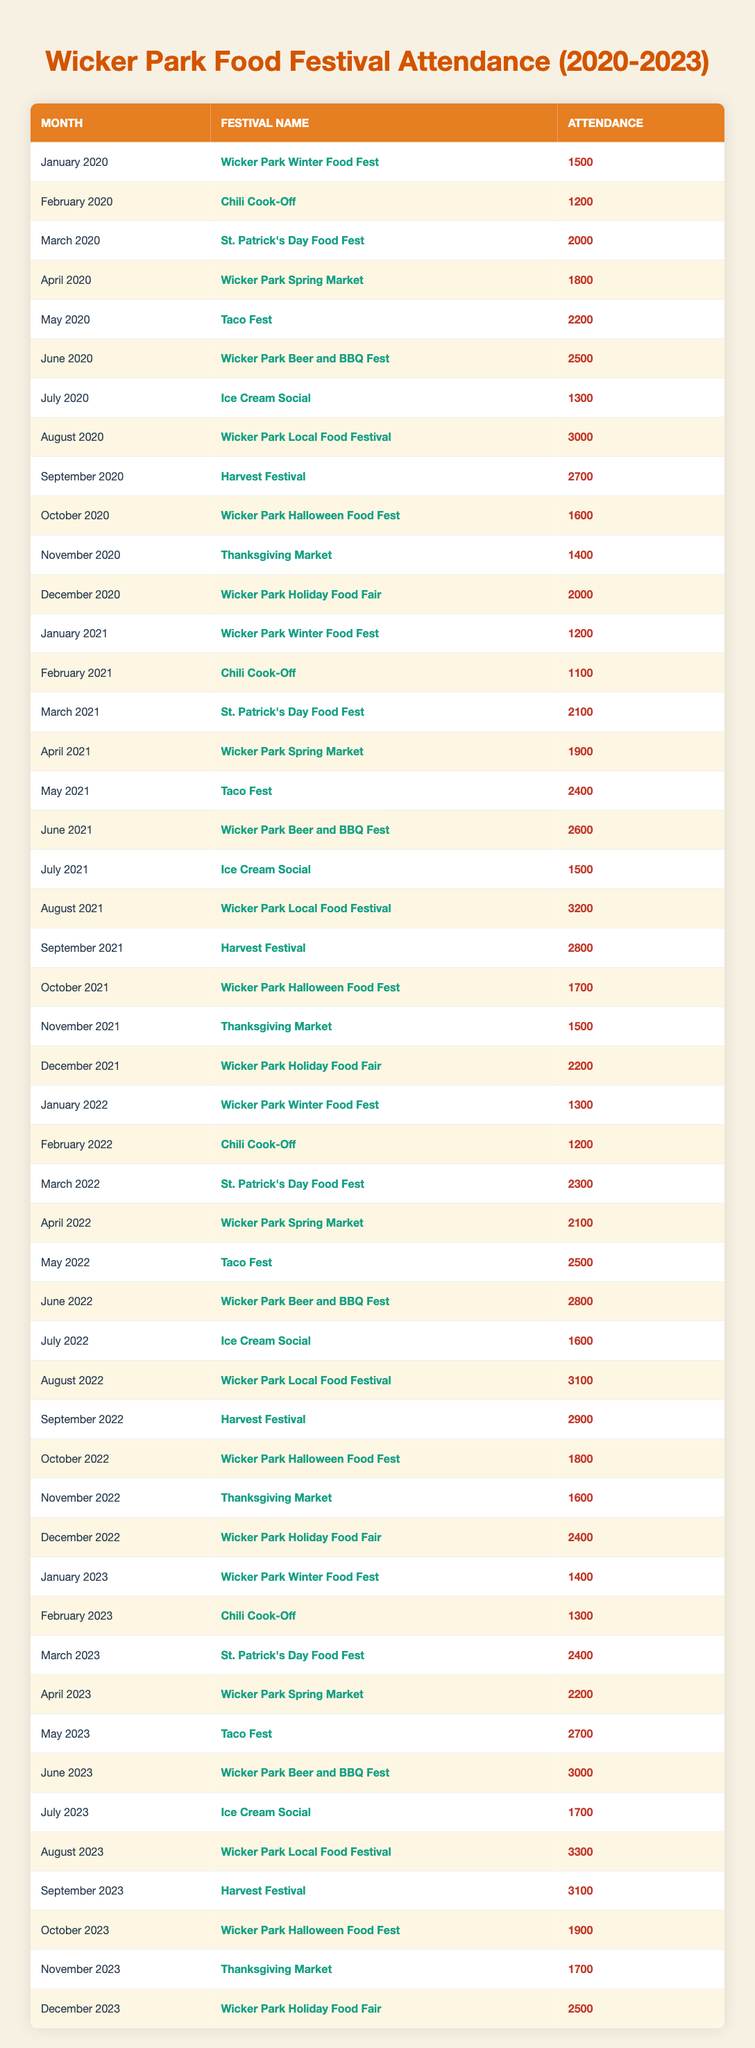What was the highest attendance at a food festival in Wicker Park from 2020 to 2023? Looking through the attendance data, the highest number is found in August 2023 with 3300 attendees at the Wicker Park Local Food Festival.
Answer: 3300 Which food festival had the lowest attendance and what was that attendance? Scanning the table, the festival with the lowest attendance is the Chili Cook-Off in February 2021, with an attendance of 1100.
Answer: 1100 What is the total attendance for the Wicker Park Beer and BBQ Fest over the four years? The attendances are 2500 (June 2020), 2600 (June 2021), 2800 (June 2022), and 3000 (June 2023). Adding these together: 2500 + 2600 + 2800 + 3000 = 10900.
Answer: 10900 Did the August food festival have higher attendance in 2023 than in 2022? In August 2023, the attendance was 3300, while in August 2022 it was 3100. Since 3300 is greater than 3100, the answer is yes.
Answer: Yes What was the attendance difference between the Wicker Park Local Food Festivals in 2021 and 2022? The attendance for the Wicker Park Local Food Festival in 2021 was 3200, and in 2022 it was 3100. The difference is 3200 - 3100 = 100.
Answer: 100 Is the total attendance for the Wicker Park Halloween Food Fest in 2020 greater than in 2023? The attendance in October 2020 was 1600, while in October 2023 it was 1900. Since 1600 is less than 1900, the answer is no.
Answer: No What was the average attendance for food festivals held in December from 2020 to 2023? The attendances for December are 2000 (2020), 2200 (2021), 2400 (2022), and 2500 (2023). To calculate the average: (2000 + 2200 + 2400 + 2500) / 4 = 2275.
Answer: 2275 Which month in 2022 had a higher attendance: April or May? In April 2022, the attendance was 2100 and in May 2022 it was 2500. Since 2500 is greater than 2100, May had higher attendance.
Answer: May What was the total attendance for all the festivals held in March over the three years? The attendances for March are 2000 (2020), 2100 (2021), and 2300 (2022), and 2400 (2023). Adding these numbers gives: 2000 + 2100 + 2300 + 2400 = 8800.
Answer: 8800 